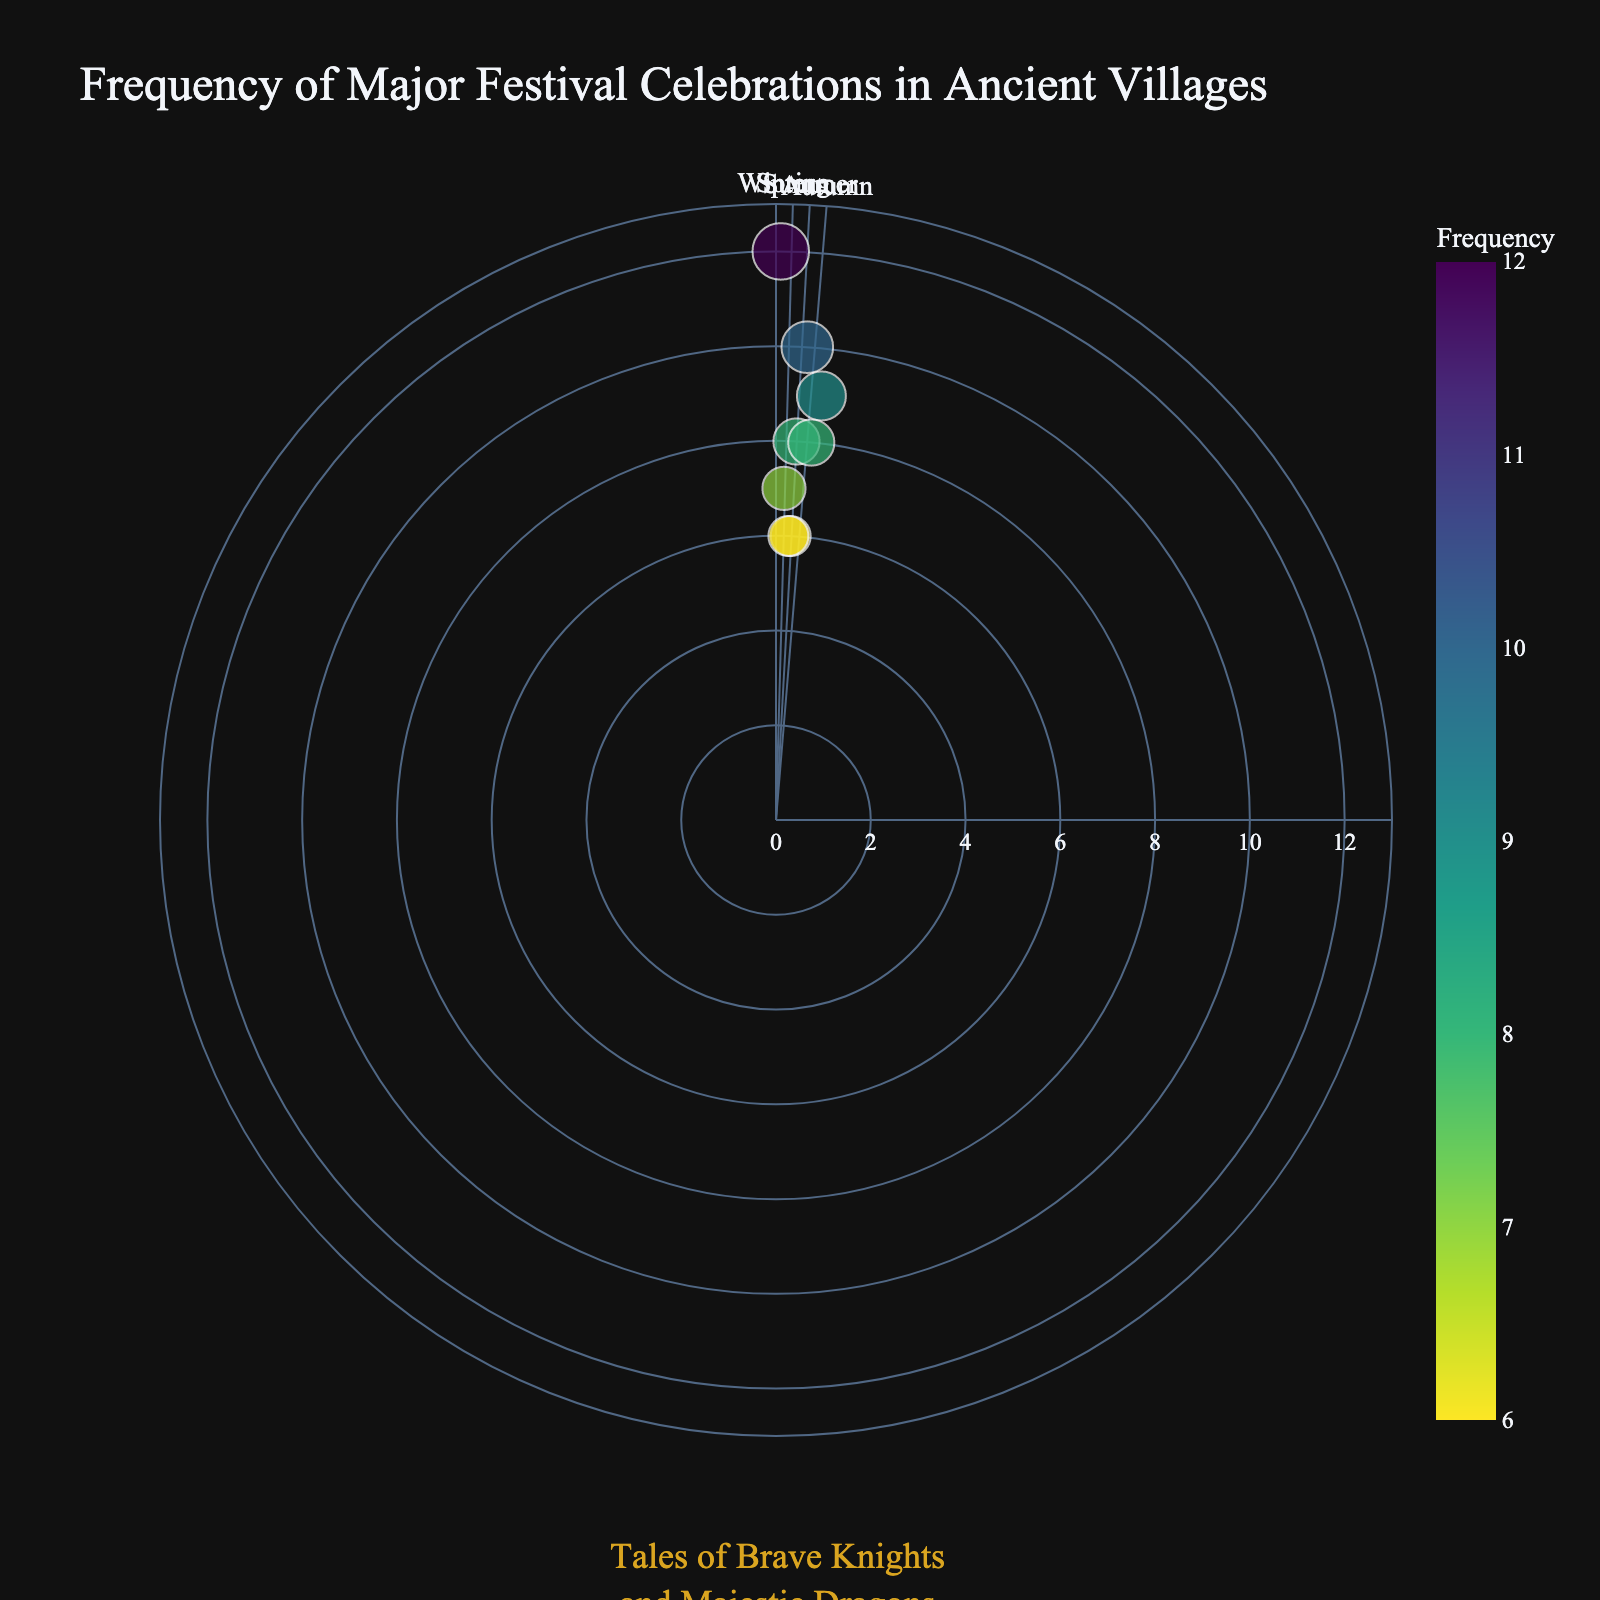What festival has the highest frequency of celebration? Scan the plot for the data point with the largest radial distance, which corresponds to the highest frequency. The label should reveal the festival with the highest frequency.
Answer: New Moon Ritual Which season sees the highest frequency of celebrations? Identify the data points clustered within each seasonal segment on the polar plot. Sum the frequencies of the festivals within each season and compare.
Answer: Winter How many festivals have a frequency of 8 celebrations? Count the number of data points that have their radial distance indicating a frequency of 8. The hover names or labels can confirm the festivals.
Answer: Two Which season hosts the Dragon Feast? Locate the data point labeled "Dragon Feast" and determine which seasonal segment (Winter, Spring, Summer, Autumn) it falls within based on its angular position.
Answer: Autumn What is the average frequency of the festivals in Summer? Identify the festivals in the "Summer" section (Midsummer Festival) and calculate the average of their frequencies.
Answer: 6 Which festival is celebrated closest to the Spring Equinox? Check the angular proximity of the data points to the "Spring Equinox" label and find the closest one.
Answer: Knight's Joust Which festival has the lowest frequency of celebration? Scan the plot for the data point with the smallest radial distance, which corresponds to the lowest frequency. The label should indicate the festival.
Answer: Midsummer Festival What is the difference in frequency between the Winter Solstice and the Harvest Festival? Identify and compare the frequencies of the "Winter Solstice" and "Harvest Festival" points from the plot. Calculate the difference.
Answer: 1 